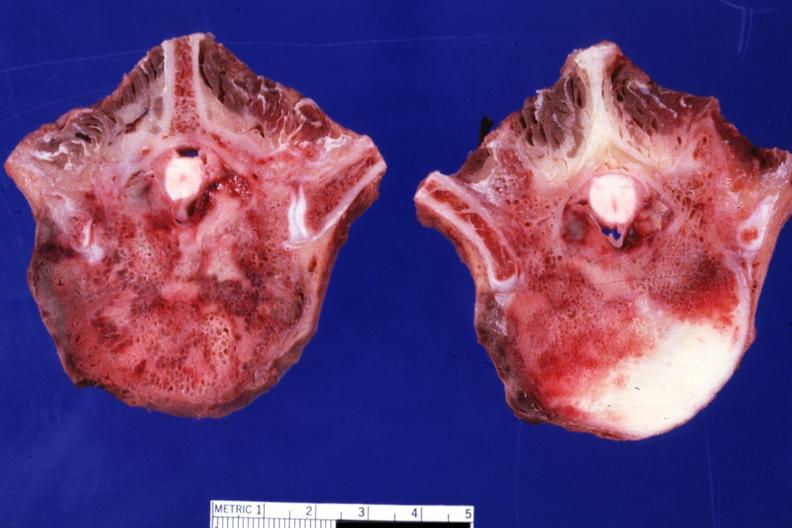what is present?
Answer the question using a single word or phrase. Joints 